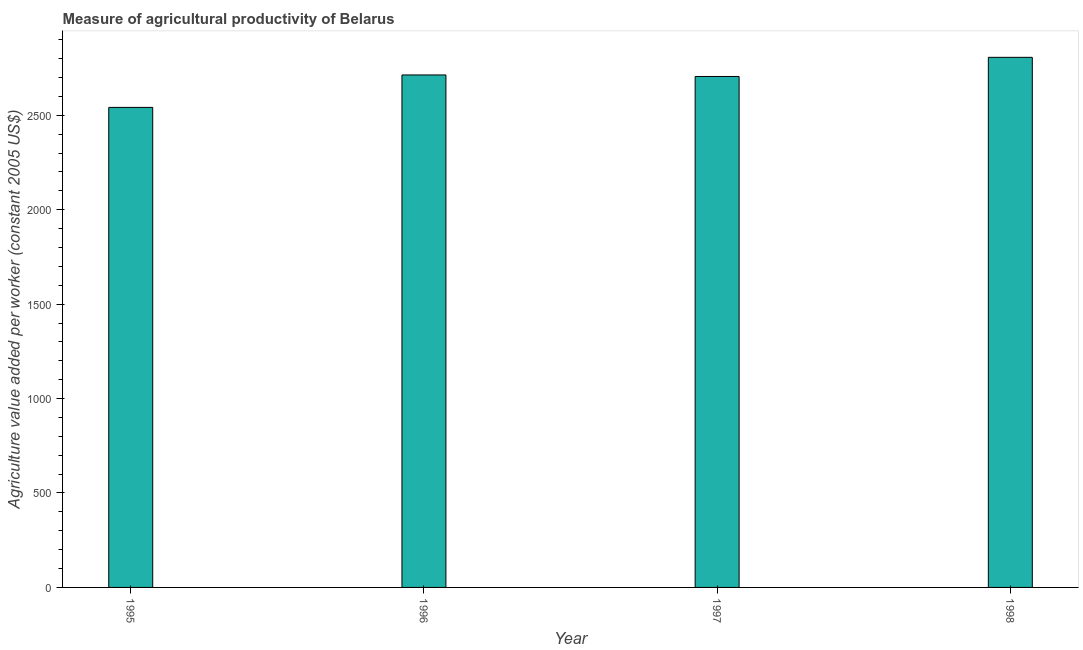What is the title of the graph?
Offer a very short reply. Measure of agricultural productivity of Belarus. What is the label or title of the Y-axis?
Offer a very short reply. Agriculture value added per worker (constant 2005 US$). What is the agriculture value added per worker in 1995?
Provide a succinct answer. 2541.67. Across all years, what is the maximum agriculture value added per worker?
Offer a very short reply. 2806.81. Across all years, what is the minimum agriculture value added per worker?
Provide a short and direct response. 2541.67. In which year was the agriculture value added per worker maximum?
Make the answer very short. 1998. In which year was the agriculture value added per worker minimum?
Your answer should be very brief. 1995. What is the sum of the agriculture value added per worker?
Give a very brief answer. 1.08e+04. What is the difference between the agriculture value added per worker in 1997 and 1998?
Keep it short and to the point. -101.35. What is the average agriculture value added per worker per year?
Offer a very short reply. 2691.86. What is the median agriculture value added per worker?
Make the answer very short. 2709.49. What is the ratio of the agriculture value added per worker in 1995 to that in 1996?
Provide a short and direct response. 0.94. Is the difference between the agriculture value added per worker in 1997 and 1998 greater than the difference between any two years?
Give a very brief answer. No. What is the difference between the highest and the second highest agriculture value added per worker?
Provide a succinct answer. 93.3. What is the difference between the highest and the lowest agriculture value added per worker?
Keep it short and to the point. 265.14. How many bars are there?
Offer a very short reply. 4. Are the values on the major ticks of Y-axis written in scientific E-notation?
Your answer should be very brief. No. What is the Agriculture value added per worker (constant 2005 US$) in 1995?
Give a very brief answer. 2541.67. What is the Agriculture value added per worker (constant 2005 US$) of 1996?
Provide a short and direct response. 2713.51. What is the Agriculture value added per worker (constant 2005 US$) of 1997?
Offer a terse response. 2705.46. What is the Agriculture value added per worker (constant 2005 US$) in 1998?
Your answer should be compact. 2806.81. What is the difference between the Agriculture value added per worker (constant 2005 US$) in 1995 and 1996?
Your response must be concise. -171.84. What is the difference between the Agriculture value added per worker (constant 2005 US$) in 1995 and 1997?
Ensure brevity in your answer.  -163.79. What is the difference between the Agriculture value added per worker (constant 2005 US$) in 1995 and 1998?
Provide a short and direct response. -265.14. What is the difference between the Agriculture value added per worker (constant 2005 US$) in 1996 and 1997?
Provide a short and direct response. 8.05. What is the difference between the Agriculture value added per worker (constant 2005 US$) in 1996 and 1998?
Provide a short and direct response. -93.3. What is the difference between the Agriculture value added per worker (constant 2005 US$) in 1997 and 1998?
Give a very brief answer. -101.35. What is the ratio of the Agriculture value added per worker (constant 2005 US$) in 1995 to that in 1996?
Offer a terse response. 0.94. What is the ratio of the Agriculture value added per worker (constant 2005 US$) in 1995 to that in 1997?
Your response must be concise. 0.94. What is the ratio of the Agriculture value added per worker (constant 2005 US$) in 1995 to that in 1998?
Give a very brief answer. 0.91. What is the ratio of the Agriculture value added per worker (constant 2005 US$) in 1996 to that in 1998?
Offer a terse response. 0.97. 